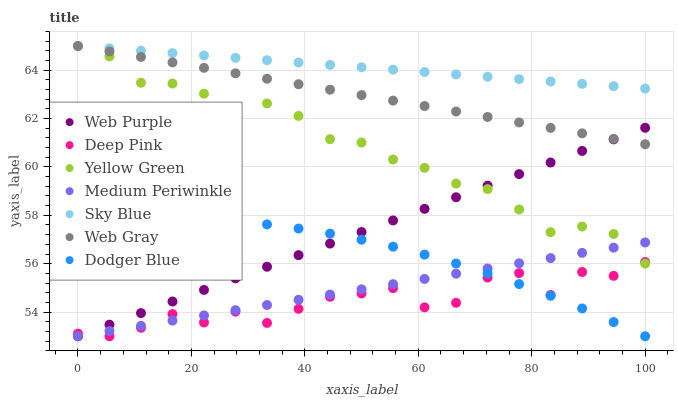Does Deep Pink have the minimum area under the curve?
Answer yes or no. Yes. Does Sky Blue have the maximum area under the curve?
Answer yes or no. Yes. Does Yellow Green have the minimum area under the curve?
Answer yes or no. No. Does Yellow Green have the maximum area under the curve?
Answer yes or no. No. Is Medium Periwinkle the smoothest?
Answer yes or no. Yes. Is Deep Pink the roughest?
Answer yes or no. Yes. Is Yellow Green the smoothest?
Answer yes or no. No. Is Yellow Green the roughest?
Answer yes or no. No. Does Medium Periwinkle have the lowest value?
Answer yes or no. Yes. Does Yellow Green have the lowest value?
Answer yes or no. No. Does Sky Blue have the highest value?
Answer yes or no. Yes. Does Medium Periwinkle have the highest value?
Answer yes or no. No. Is Medium Periwinkle less than Sky Blue?
Answer yes or no. Yes. Is Web Gray greater than Medium Periwinkle?
Answer yes or no. Yes. Does Web Purple intersect Medium Periwinkle?
Answer yes or no. Yes. Is Web Purple less than Medium Periwinkle?
Answer yes or no. No. Is Web Purple greater than Medium Periwinkle?
Answer yes or no. No. Does Medium Periwinkle intersect Sky Blue?
Answer yes or no. No. 